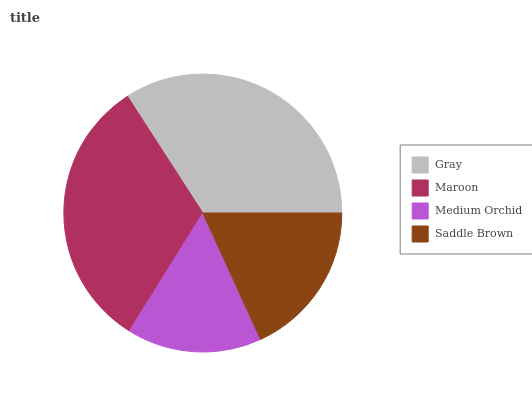Is Medium Orchid the minimum?
Answer yes or no. Yes. Is Gray the maximum?
Answer yes or no. Yes. Is Maroon the minimum?
Answer yes or no. No. Is Maroon the maximum?
Answer yes or no. No. Is Gray greater than Maroon?
Answer yes or no. Yes. Is Maroon less than Gray?
Answer yes or no. Yes. Is Maroon greater than Gray?
Answer yes or no. No. Is Gray less than Maroon?
Answer yes or no. No. Is Maroon the high median?
Answer yes or no. Yes. Is Saddle Brown the low median?
Answer yes or no. Yes. Is Medium Orchid the high median?
Answer yes or no. No. Is Medium Orchid the low median?
Answer yes or no. No. 